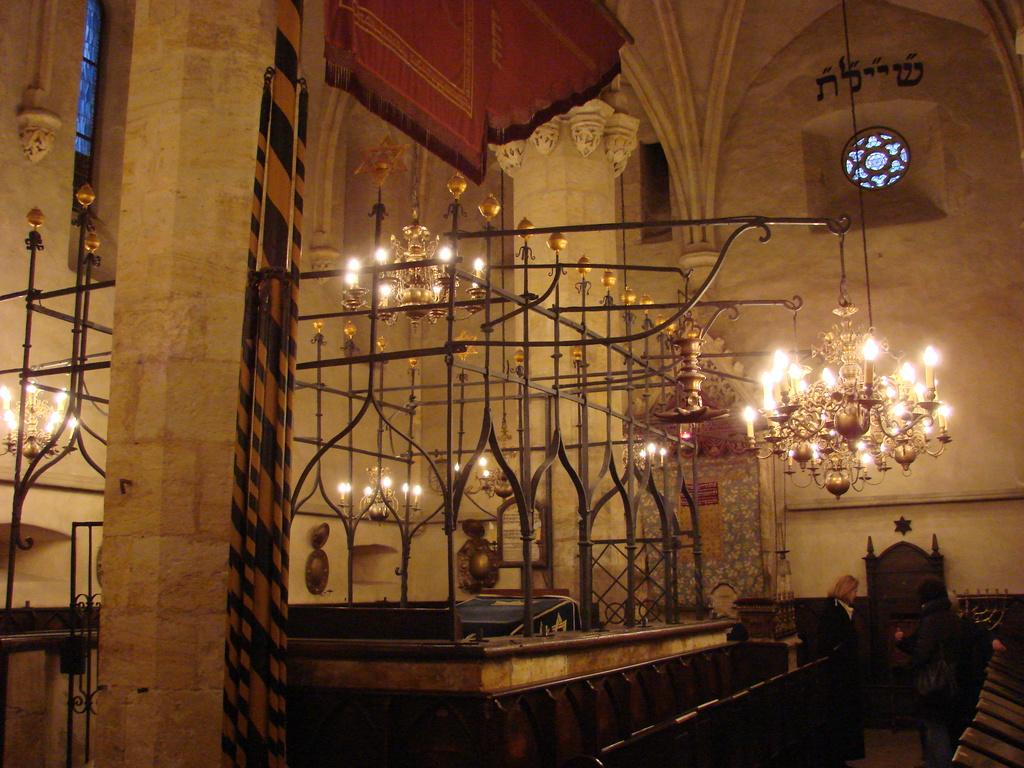What is the main structure in the middle of the image? There is an iron grill in the middle of the image. What can be seen illuminating the area in the image? There are lights visible in the image. Who is present on the right side of the image? Two persons are standing on the right side of the image. What type of location does the image appear to depict? The setting appears to be the inside part of a fort. How many beds can be seen in the image? There are no beds visible in the image. What type of camera is being used to take the picture? The image does not provide information about the camera used to capture it. 